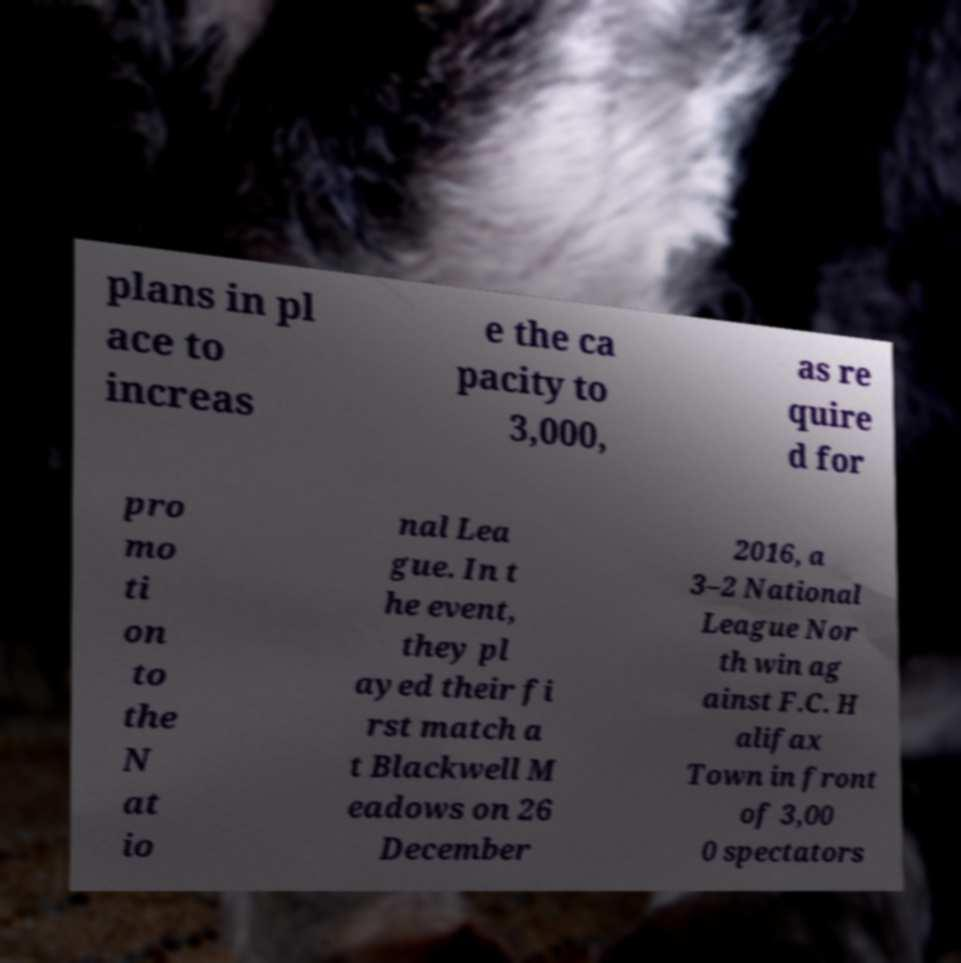Please read and relay the text visible in this image. What does it say? plans in pl ace to increas e the ca pacity to 3,000, as re quire d for pro mo ti on to the N at io nal Lea gue. In t he event, they pl ayed their fi rst match a t Blackwell M eadows on 26 December 2016, a 3–2 National League Nor th win ag ainst F.C. H alifax Town in front of 3,00 0 spectators 